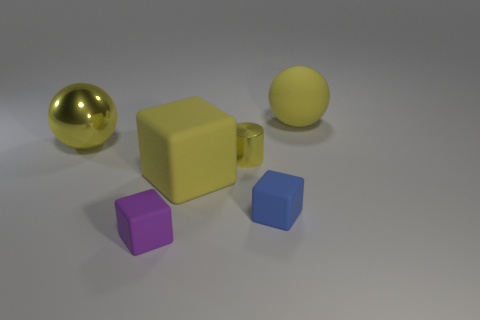Add 1 yellow spheres. How many objects exist? 7 Subtract all cylinders. How many objects are left? 5 Add 1 balls. How many balls are left? 3 Add 5 large red matte cubes. How many large red matte cubes exist? 5 Subtract 0 green blocks. How many objects are left? 6 Subtract all big objects. Subtract all big yellow balls. How many objects are left? 1 